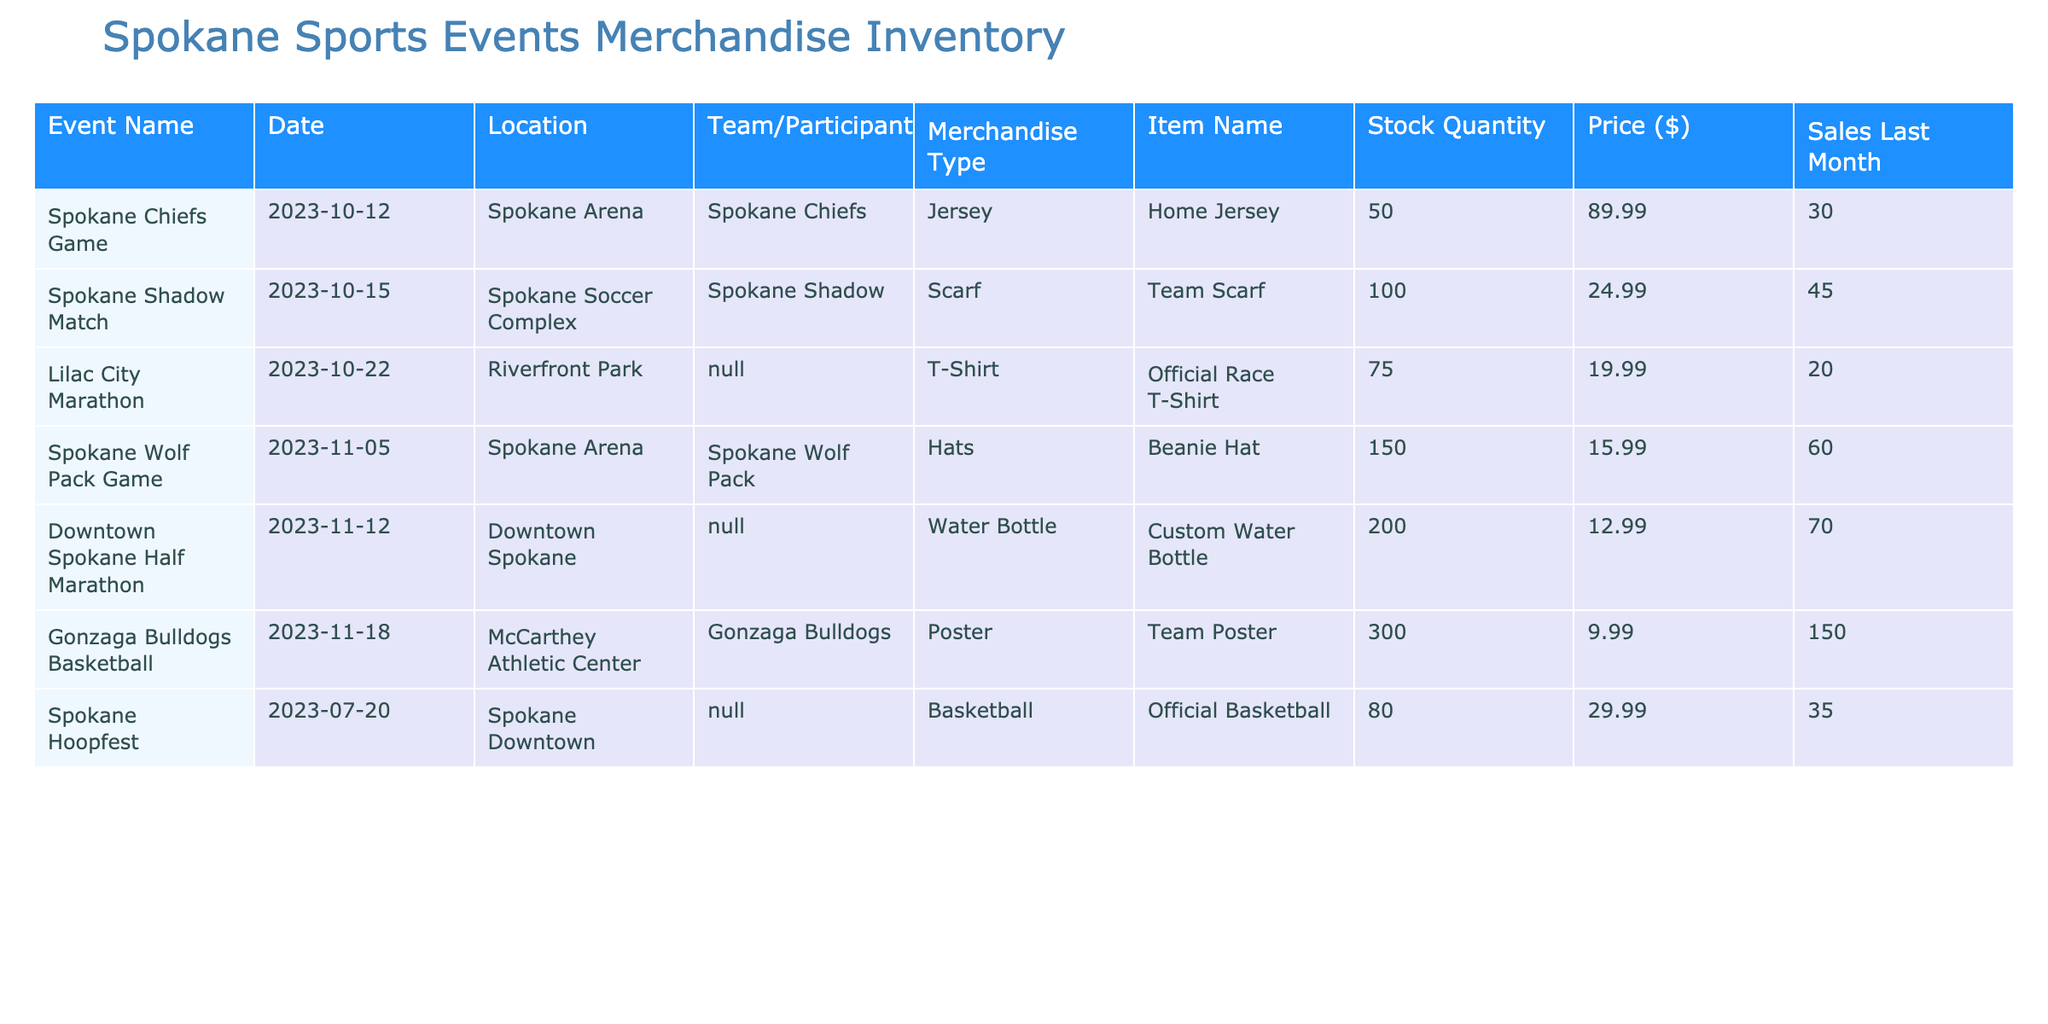What is the stock quantity of the Home Jersey? The stock quantity for the Home Jersey is listed in the row for the Spokane Chiefs Game. Referencing that row, we see that the stock quantity is 50.
Answer: 50 Which event has the highest stock quantity of merchandise? By reviewing the stock quantities of all events, the Downtown Spokane Half Marathon has 200 stock quantity, which is the highest when compared to other events.
Answer: 200 Is there any event with merchandise priced under $15? Upon checking the merchandise prices for each event, the pricing for all items is either $12.99 or above, therefore there is no event with merchandise priced under $15.
Answer: No What is the total sales from the last month for all merchandise? To find the total sales from the last month, sum up the sales from all items: 30 + 45 + 20 + 60 + 70 + 150 + 35 = 410. Hence, the total sales from the last month for all merchandise is 410.
Answer: 410 How many hats are available compared to jerseys? The Spokane Wolf Pack has 150 Beanie Hats available in stock, while the Spokane Chiefs have 50 Home Jerseys in stock. Thus, there are three times more hats than jerseys: 150 - 50 equals 100 more hats.
Answer: 100 more hats What percentage of the stock quantity for Team Scarves was sold last month? To determine the percentage sold, divide the sales last month (45) by the stock quantity (100) and multiply by 100: (45 / 100) * 100 = 45%. This means that 45% of the Team Scarves stock was sold last month.
Answer: 45% Which merchandise item sold the most last month? By examining the sales last month for each merchandise item, the Gonzaga Bulldogs Team Poster had the highest sales at 150 units sold, more than any other item listed.
Answer: Team Poster What is the average price of merchandise across the events listed? To find the average price, sum the prices of all items: 89.99 + 24.99 + 19.99 + 15.99 + 12.99 + 9.99 + 29.99 = 203.92. There are 7 items, so the average price is 203.92 / 7 which is approximately 29.13.
Answer: 29.13 